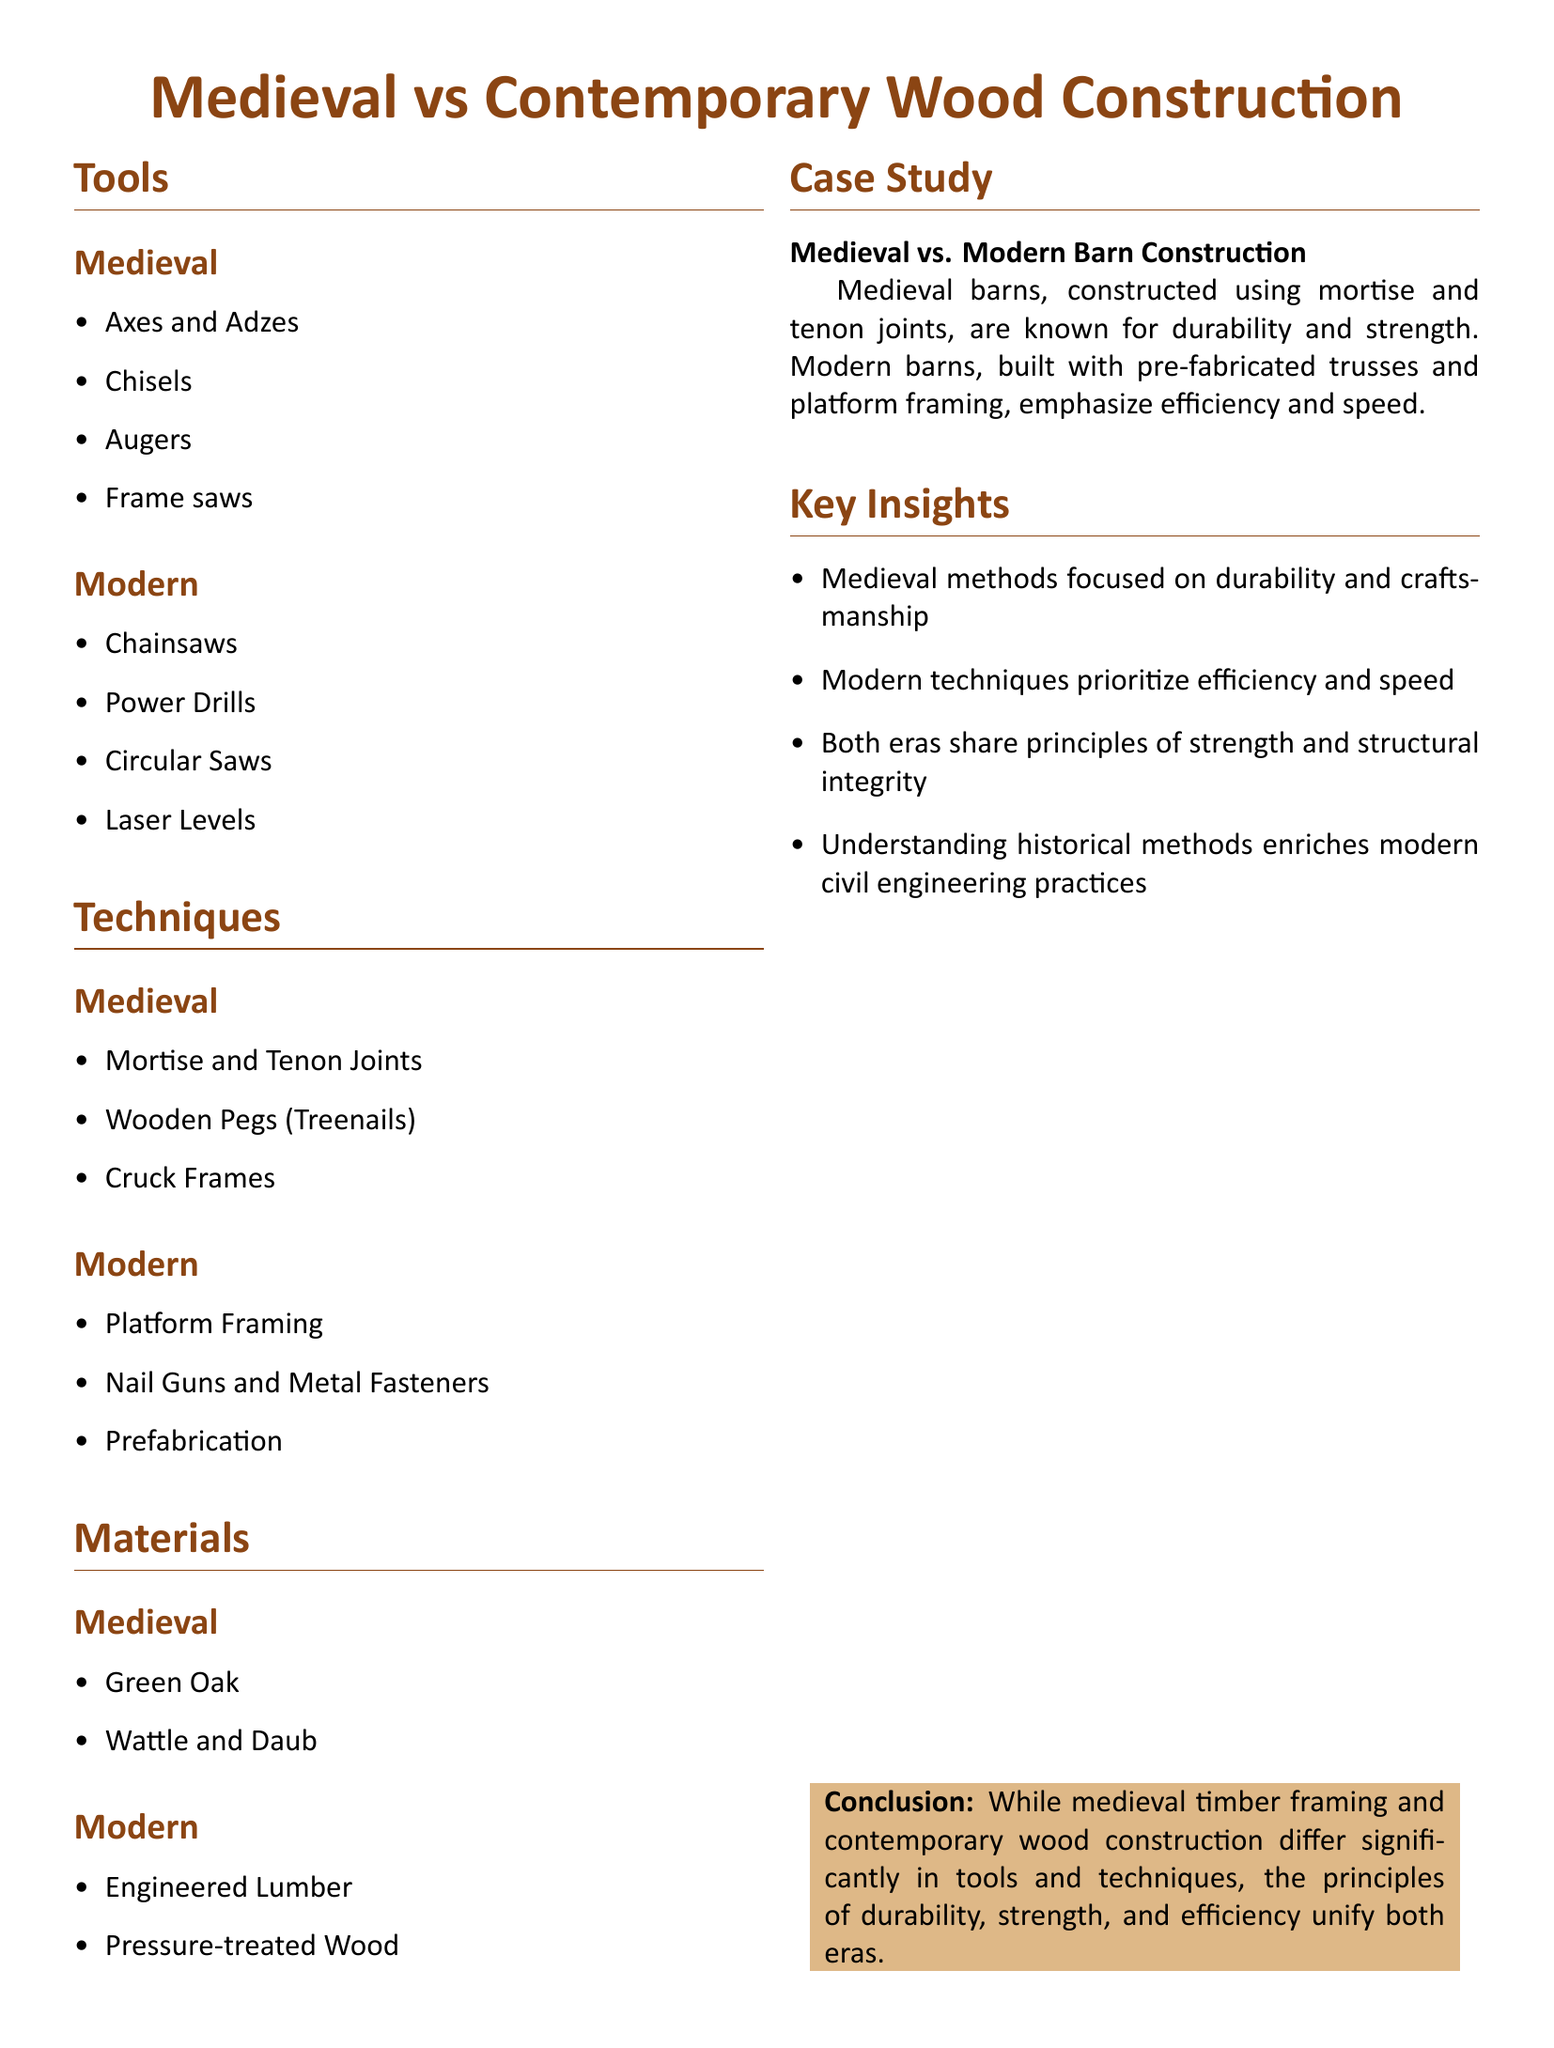What are some tools used in medieval wood construction? The document lists tools for medieval wood construction under the "Tools" section, which includes specific items like axes and adzes, chisels, augers, and frame saws.
Answer: Axes and Adzes, Chisels, Augers, Frame saws What kind of wood is primarily mentioned as a material used in medieval construction? In the "Materials" section, it lists green oak as a primary wood used in medieval construction methods.
Answer: Green Oak What modern technique prioritizes speed in construction? The modern techniques section lists prefabrication, which focuses on speedy assembly and efficiency in building.
Answer: Prefabrication How does the document describe medieval barns? The "Case Study" section describes medieval barns as known for durability and strength, emphasizing traditional construction methods.
Answer: Known for durability and strength Which modern tool allows precise cutting compared to medieval methods? The tools section highlights modern chainsaws as precise and efficient cutting tools, contrasting with medieval axes and adzes.
Answer: Chainsaws What is the conclusion regarding the principles that unify both medieval and modern construction methods? The conclusion section asserts that durability, strength, and efficiency are principles that unify both construction methods despite technological differences.
Answer: Durability, strength, and efficiency 